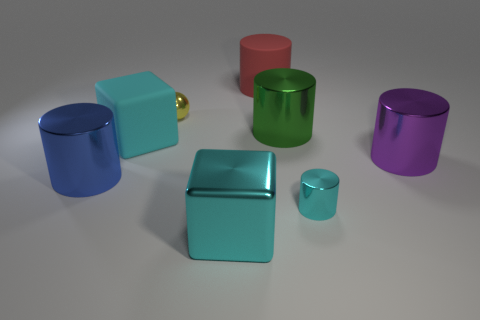Subtract 1 cylinders. How many cylinders are left? 4 Subtract all brown cylinders. Subtract all purple cubes. How many cylinders are left? 5 Add 1 green metal cylinders. How many objects exist? 9 Subtract all balls. How many objects are left? 7 Subtract all large yellow metal things. Subtract all purple objects. How many objects are left? 7 Add 4 big things. How many big things are left? 10 Add 1 large red cylinders. How many large red cylinders exist? 2 Subtract 1 blue cylinders. How many objects are left? 7 